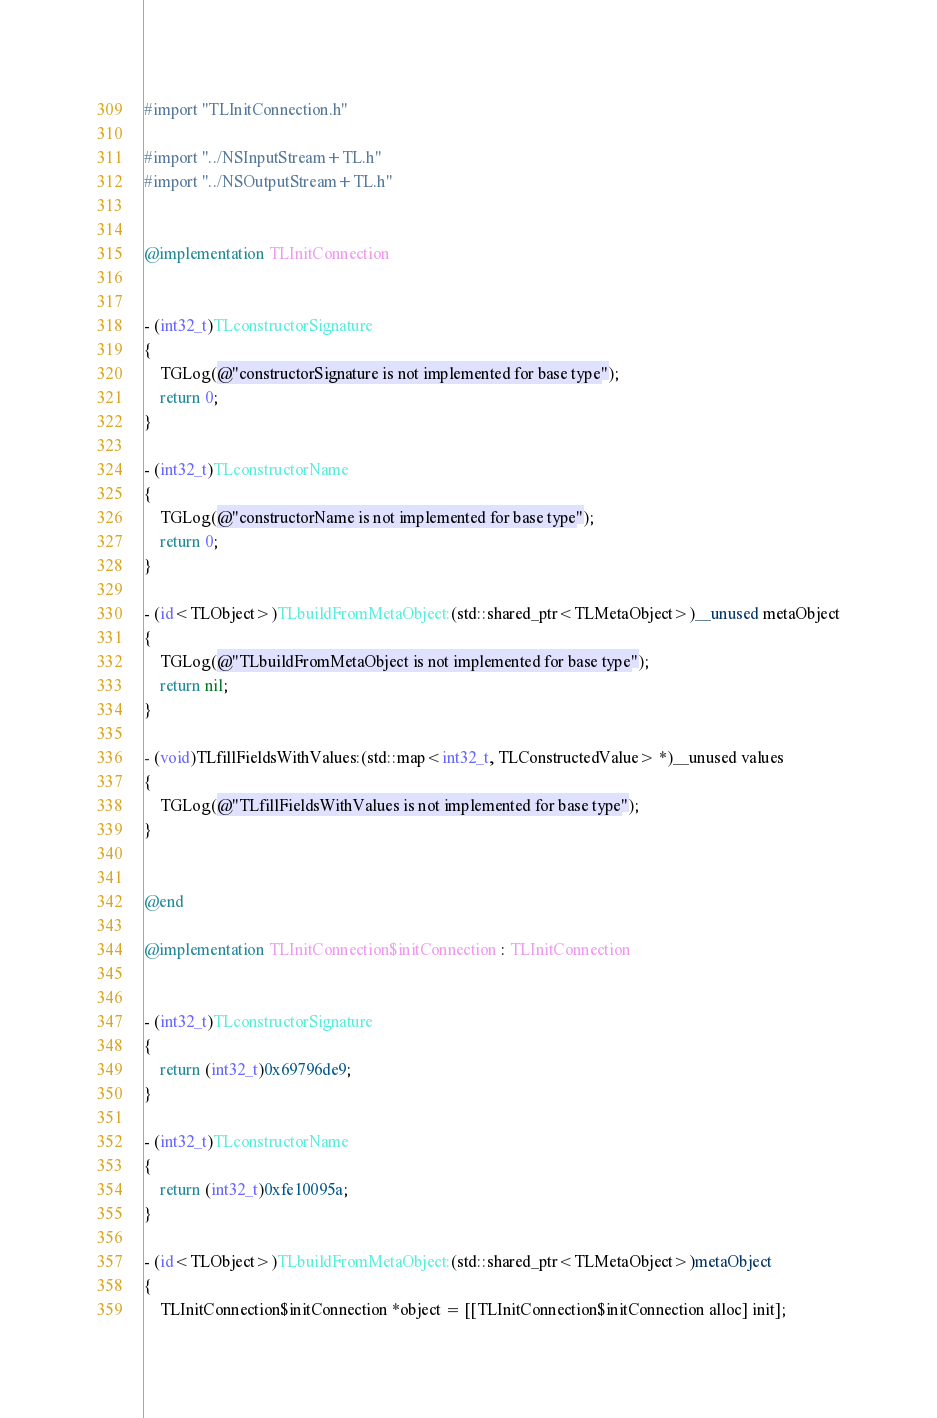<code> <loc_0><loc_0><loc_500><loc_500><_ObjectiveC_>#import "TLInitConnection.h"

#import "../NSInputStream+TL.h"
#import "../NSOutputStream+TL.h"


@implementation TLInitConnection


- (int32_t)TLconstructorSignature
{
    TGLog(@"constructorSignature is not implemented for base type");
    return 0;
}

- (int32_t)TLconstructorName
{
    TGLog(@"constructorName is not implemented for base type");
    return 0;
}

- (id<TLObject>)TLbuildFromMetaObject:(std::shared_ptr<TLMetaObject>)__unused metaObject
{
    TGLog(@"TLbuildFromMetaObject is not implemented for base type");
    return nil;
}

- (void)TLfillFieldsWithValues:(std::map<int32_t, TLConstructedValue> *)__unused values
{
    TGLog(@"TLfillFieldsWithValues is not implemented for base type");
}


@end

@implementation TLInitConnection$initConnection : TLInitConnection


- (int32_t)TLconstructorSignature
{
    return (int32_t)0x69796de9;
}

- (int32_t)TLconstructorName
{
    return (int32_t)0xfe10095a;
}

- (id<TLObject>)TLbuildFromMetaObject:(std::shared_ptr<TLMetaObject>)metaObject
{
    TLInitConnection$initConnection *object = [[TLInitConnection$initConnection alloc] init];</code> 